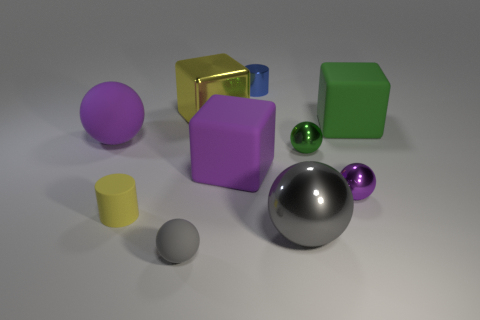There is a big block that is the same color as the big rubber ball; what material is it?
Keep it short and to the point. Rubber. What number of big things are metal objects or green metal balls?
Ensure brevity in your answer.  2. There is a large purple object on the right side of the rubber cylinder; what is its shape?
Your answer should be compact. Cube. Are there any things that have the same color as the tiny matte cylinder?
Your response must be concise. Yes. Does the gray object that is left of the blue thing have the same size as the thing that is behind the large metal cube?
Provide a short and direct response. Yes. Are there more large green things behind the small purple shiny ball than tiny yellow objects that are behind the tiny yellow matte cylinder?
Provide a short and direct response. Yes. Is there a small green sphere that has the same material as the yellow cylinder?
Offer a terse response. No. Does the large metallic cube have the same color as the matte cylinder?
Make the answer very short. Yes. What is the material of the purple object that is both behind the tiny purple sphere and right of the small gray thing?
Give a very brief answer. Rubber. The matte cylinder is what color?
Make the answer very short. Yellow. 